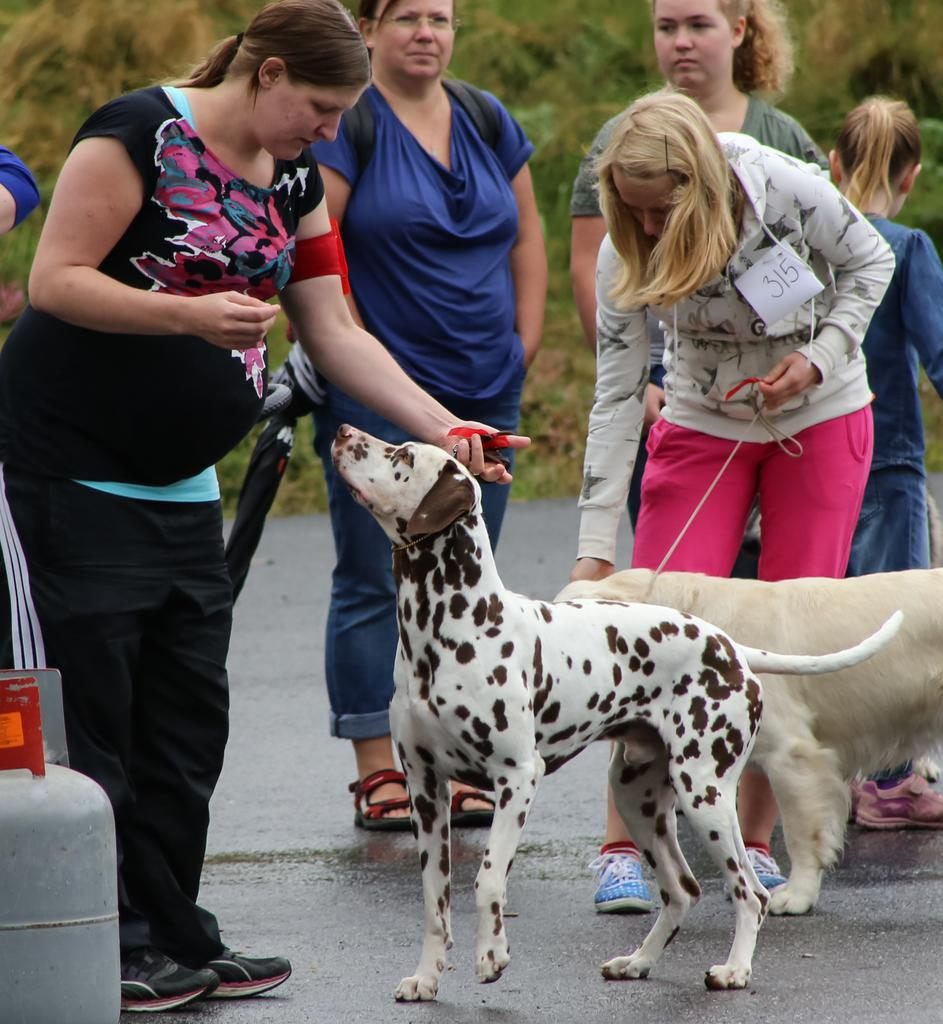What is happening in the image involving the group of women? The women are pampering dogs in the image. Where are the dogs located in the image? The dogs are on the road in the image. What can be seen to the left in the image? There is a cylinder to the left in the image. What is the condition of the road in the image? The road is wet in the image. What type of vegetation is visible in the background of the image? There are trees and grass in the background of the image. Are there any fairies visible in the image? There are no fairies present in the image. What is the birth rate of the dogs in the image? There is no information about the birth rate of the dogs in the image. 